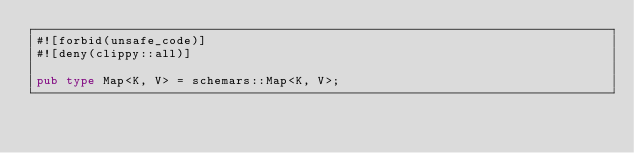Convert code to text. <code><loc_0><loc_0><loc_500><loc_500><_Rust_>#![forbid(unsafe_code)]
#![deny(clippy::all)]

pub type Map<K, V> = schemars::Map<K, V>;</code> 